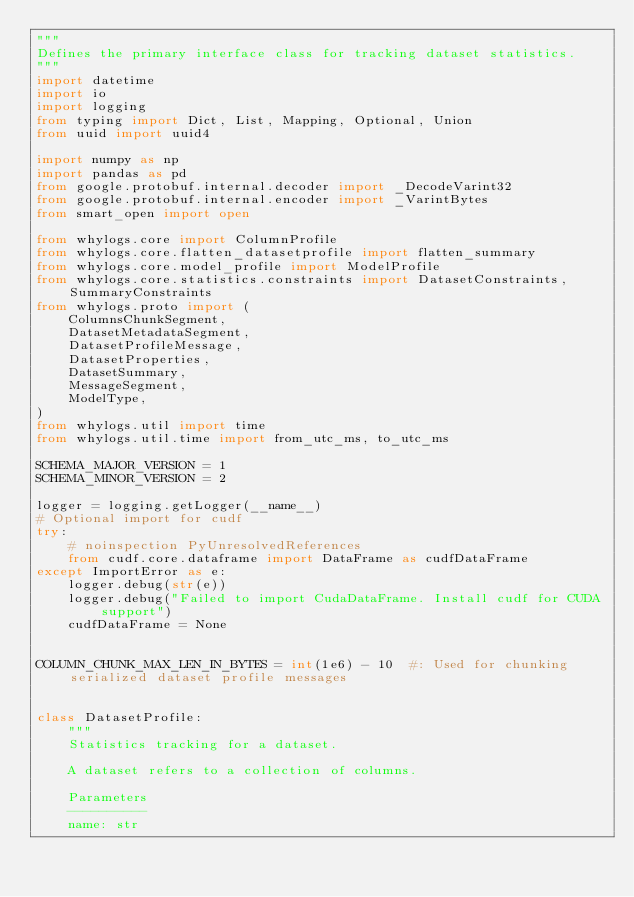Convert code to text. <code><loc_0><loc_0><loc_500><loc_500><_Python_>"""
Defines the primary interface class for tracking dataset statistics.
"""
import datetime
import io
import logging
from typing import Dict, List, Mapping, Optional, Union
from uuid import uuid4

import numpy as np
import pandas as pd
from google.protobuf.internal.decoder import _DecodeVarint32
from google.protobuf.internal.encoder import _VarintBytes
from smart_open import open

from whylogs.core import ColumnProfile
from whylogs.core.flatten_datasetprofile import flatten_summary
from whylogs.core.model_profile import ModelProfile
from whylogs.core.statistics.constraints import DatasetConstraints, SummaryConstraints
from whylogs.proto import (
    ColumnsChunkSegment,
    DatasetMetadataSegment,
    DatasetProfileMessage,
    DatasetProperties,
    DatasetSummary,
    MessageSegment,
    ModelType,
)
from whylogs.util import time
from whylogs.util.time import from_utc_ms, to_utc_ms

SCHEMA_MAJOR_VERSION = 1
SCHEMA_MINOR_VERSION = 2

logger = logging.getLogger(__name__)
# Optional import for cudf
try:
    # noinspection PyUnresolvedReferences
    from cudf.core.dataframe import DataFrame as cudfDataFrame
except ImportError as e:
    logger.debug(str(e))
    logger.debug("Failed to import CudaDataFrame. Install cudf for CUDA support")
    cudfDataFrame = None


COLUMN_CHUNK_MAX_LEN_IN_BYTES = int(1e6) - 10  #: Used for chunking serialized dataset profile messages


class DatasetProfile:
    """
    Statistics tracking for a dataset.

    A dataset refers to a collection of columns.

    Parameters
    ----------
    name: str</code> 